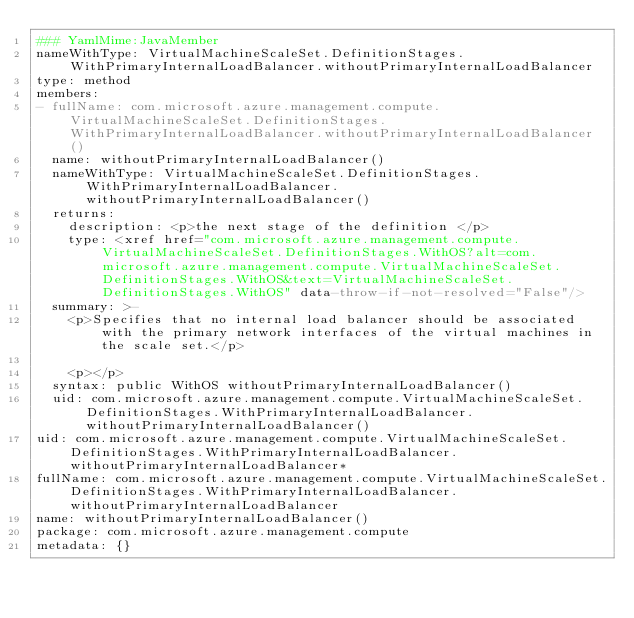<code> <loc_0><loc_0><loc_500><loc_500><_YAML_>### YamlMime:JavaMember
nameWithType: VirtualMachineScaleSet.DefinitionStages.WithPrimaryInternalLoadBalancer.withoutPrimaryInternalLoadBalancer
type: method
members:
- fullName: com.microsoft.azure.management.compute.VirtualMachineScaleSet.DefinitionStages.WithPrimaryInternalLoadBalancer.withoutPrimaryInternalLoadBalancer()
  name: withoutPrimaryInternalLoadBalancer()
  nameWithType: VirtualMachineScaleSet.DefinitionStages.WithPrimaryInternalLoadBalancer.withoutPrimaryInternalLoadBalancer()
  returns:
    description: <p>the next stage of the definition </p>
    type: <xref href="com.microsoft.azure.management.compute.VirtualMachineScaleSet.DefinitionStages.WithOS?alt=com.microsoft.azure.management.compute.VirtualMachineScaleSet.DefinitionStages.WithOS&text=VirtualMachineScaleSet.DefinitionStages.WithOS" data-throw-if-not-resolved="False"/>
  summary: >-
    <p>Specifies that no internal load balancer should be associated with the primary network interfaces of the virtual machines in the scale set.</p>

    <p></p>
  syntax: public WithOS withoutPrimaryInternalLoadBalancer()
  uid: com.microsoft.azure.management.compute.VirtualMachineScaleSet.DefinitionStages.WithPrimaryInternalLoadBalancer.withoutPrimaryInternalLoadBalancer()
uid: com.microsoft.azure.management.compute.VirtualMachineScaleSet.DefinitionStages.WithPrimaryInternalLoadBalancer.withoutPrimaryInternalLoadBalancer*
fullName: com.microsoft.azure.management.compute.VirtualMachineScaleSet.DefinitionStages.WithPrimaryInternalLoadBalancer.withoutPrimaryInternalLoadBalancer
name: withoutPrimaryInternalLoadBalancer()
package: com.microsoft.azure.management.compute
metadata: {}
</code> 